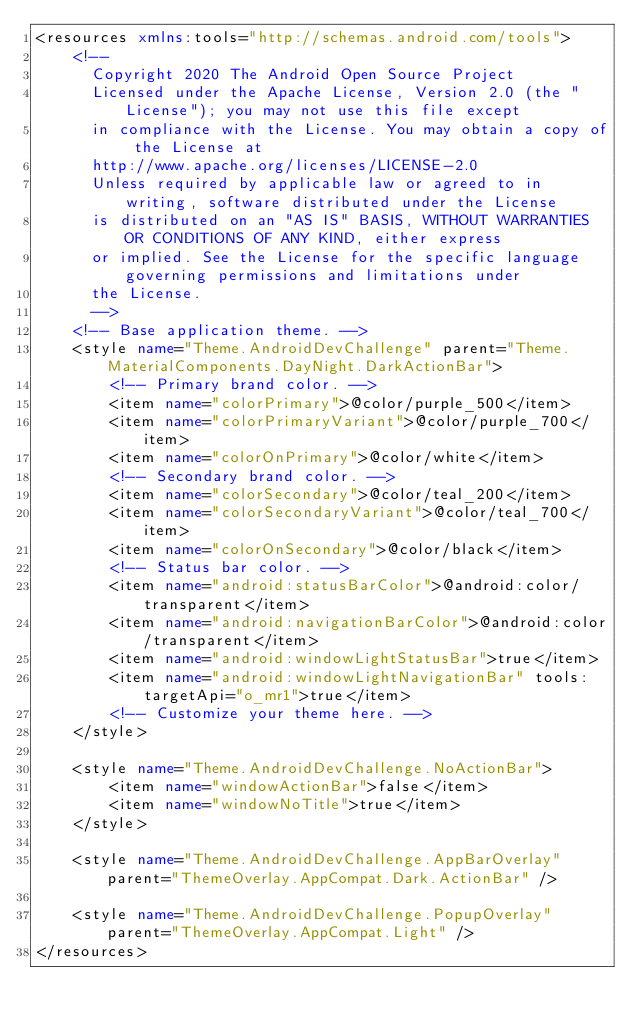Convert code to text. <code><loc_0><loc_0><loc_500><loc_500><_XML_><resources xmlns:tools="http://schemas.android.com/tools">
    <!--
      Copyright 2020 The Android Open Source Project
      Licensed under the Apache License, Version 2.0 (the "License"); you may not use this file except
      in compliance with the License. You may obtain a copy of the License at
      http://www.apache.org/licenses/LICENSE-2.0
      Unless required by applicable law or agreed to in writing, software distributed under the License
      is distributed on an "AS IS" BASIS, WITHOUT WARRANTIES OR CONDITIONS OF ANY KIND, either express
      or implied. See the License for the specific language governing permissions and limitations under
      the License.
      -->
    <!-- Base application theme. -->
    <style name="Theme.AndroidDevChallenge" parent="Theme.MaterialComponents.DayNight.DarkActionBar">
        <!-- Primary brand color. -->
        <item name="colorPrimary">@color/purple_500</item>
        <item name="colorPrimaryVariant">@color/purple_700</item>
        <item name="colorOnPrimary">@color/white</item>
        <!-- Secondary brand color. -->
        <item name="colorSecondary">@color/teal_200</item>
        <item name="colorSecondaryVariant">@color/teal_700</item>
        <item name="colorOnSecondary">@color/black</item>
        <!-- Status bar color. -->
        <item name="android:statusBarColor">@android:color/transparent</item>
        <item name="android:navigationBarColor">@android:color/transparent</item>
        <item name="android:windowLightStatusBar">true</item>
        <item name="android:windowLightNavigationBar" tools:targetApi="o_mr1">true</item>
        <!-- Customize your theme here. -->
    </style>

    <style name="Theme.AndroidDevChallenge.NoActionBar">
        <item name="windowActionBar">false</item>
        <item name="windowNoTitle">true</item>
    </style>

    <style name="Theme.AndroidDevChallenge.AppBarOverlay" parent="ThemeOverlay.AppCompat.Dark.ActionBar" />

    <style name="Theme.AndroidDevChallenge.PopupOverlay" parent="ThemeOverlay.AppCompat.Light" />
</resources></code> 